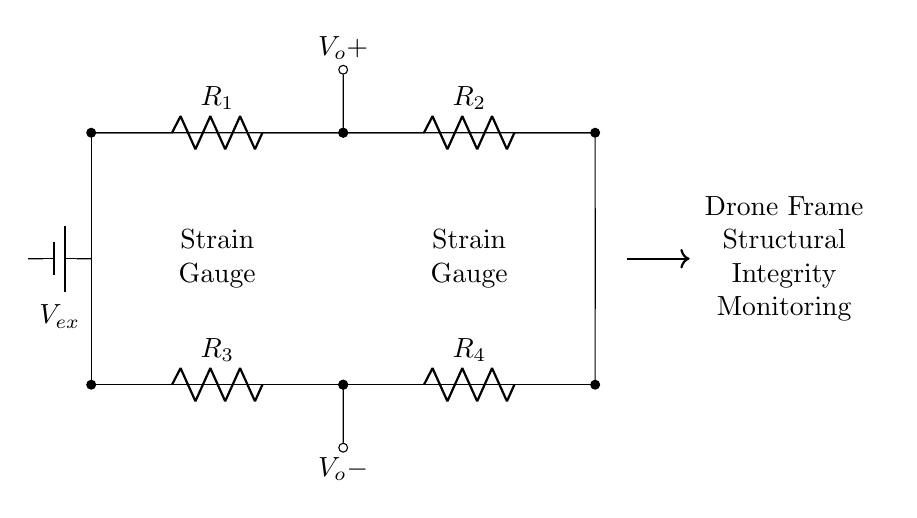What type of circuit is represented in the diagram? The circuit is a bridge circuit, commonly used for measuring electrical resistance changes, especially in strain gauges.
Answer: bridge circuit How many resistors are present in the circuit? There are a total of four resistors, labeled R1, R2, R3, and R4 in the diagram.
Answer: four What is the function of the strain gauges in this circuit? The strain gauges function as sensors that detect deformation in the drone frame, causing a change in resistance which can be measured.
Answer: sensors What is the purpose of the voltage source labeled V_ex? The voltage source provides the necessary excitation voltage for the strain gauges to function properly and allows the measurement of resistance changes.
Answer: excitation voltage What does V_o+ and V_o- represent in the circuit? V_o+ and V_o- represent the output voltage difference created by the changes in resistance due to strain, which can be monitored to assess structural integrity.
Answer: output voltage What will happen to the output voltage if one of the strain gauges experiences increased strain? If one of the strain gauges experiences increased strain, its resistance will change, leading to an imbalance in the bridge circuit and resulting in a measurable change in output voltage.
Answer: measurable change 